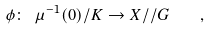Convert formula to latex. <formula><loc_0><loc_0><loc_500><loc_500>\phi \colon \ \mu ^ { - 1 } ( 0 ) / K \to X / / G \quad ,</formula> 